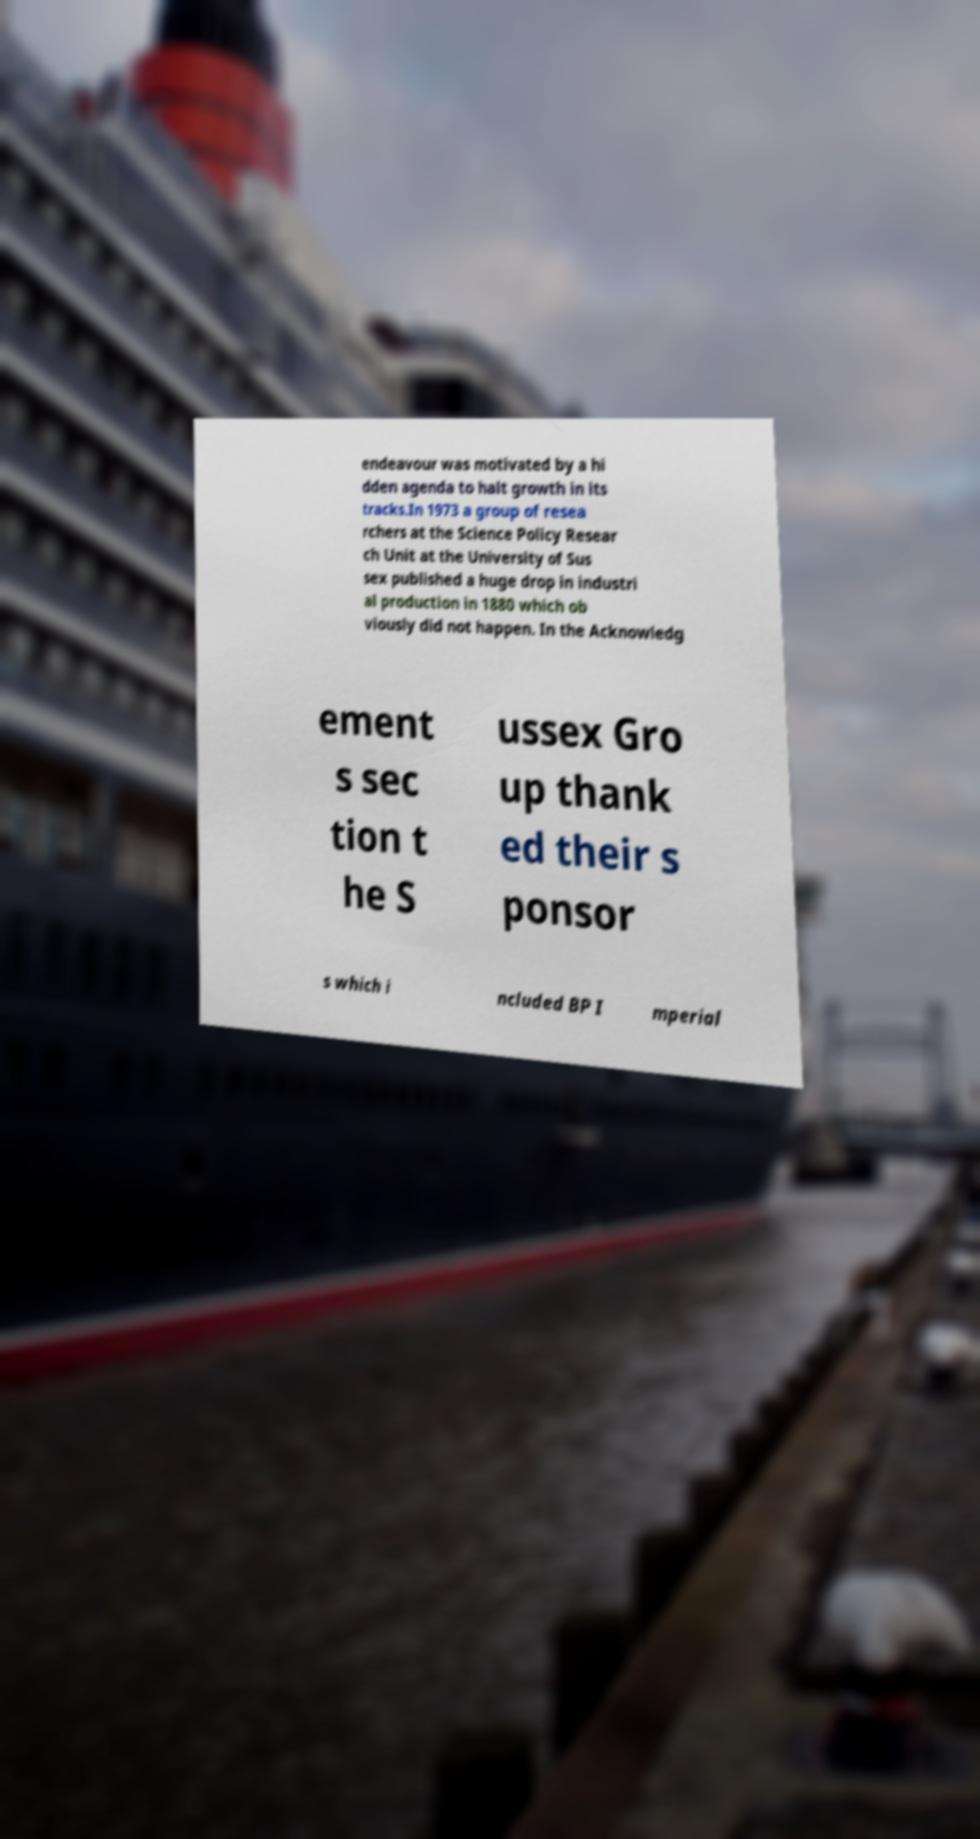Can you accurately transcribe the text from the provided image for me? endeavour was motivated by a hi dden agenda to halt growth in its tracks.In 1973 a group of resea rchers at the Science Policy Resear ch Unit at the University of Sus sex published a huge drop in industri al production in 1880 which ob viously did not happen. In the Acknowledg ement s sec tion t he S ussex Gro up thank ed their s ponsor s which i ncluded BP I mperial 